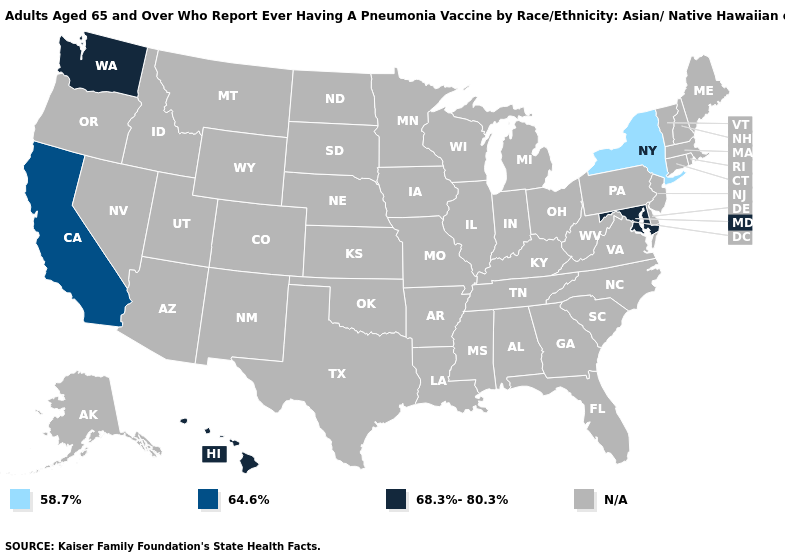What is the value of Oregon?
Answer briefly. N/A. Name the states that have a value in the range 58.7%?
Keep it brief. New York. How many symbols are there in the legend?
Answer briefly. 4. Does New York have the lowest value in the USA?
Write a very short answer. Yes. Does the first symbol in the legend represent the smallest category?
Be succinct. Yes. What is the value of Iowa?
Short answer required. N/A. What is the value of Alabama?
Quick response, please. N/A. Is the legend a continuous bar?
Write a very short answer. No. What is the lowest value in the West?
Quick response, please. 64.6%. Name the states that have a value in the range 58.7%?
Short answer required. New York. Name the states that have a value in the range 68.3%-80.3%?
Keep it brief. Hawaii, Maryland, Washington. Which states have the lowest value in the Northeast?
Give a very brief answer. New York. 